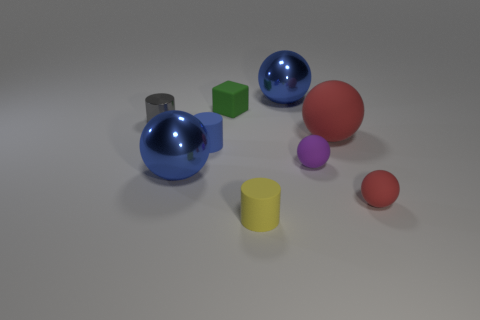Can you describe the composition and arrangement of shapes in this image? Certainly. The image features a collection of geometric shapes scattered on a flat surface. These shapes include spheres, cubes, and cylinders and come in various colors such as blue, red, green, yellow, and purple. Specifically, there are two large spheres, one red and one blue, and a smaller purple sphere. Additionally, there's a red sphere of medium size and a tiny red sphere. Two cubes are present, one large green and one small yellow, alongside two cylinders in grey and yellow. The arrangement is somewhat random, with no discernible pattern. 